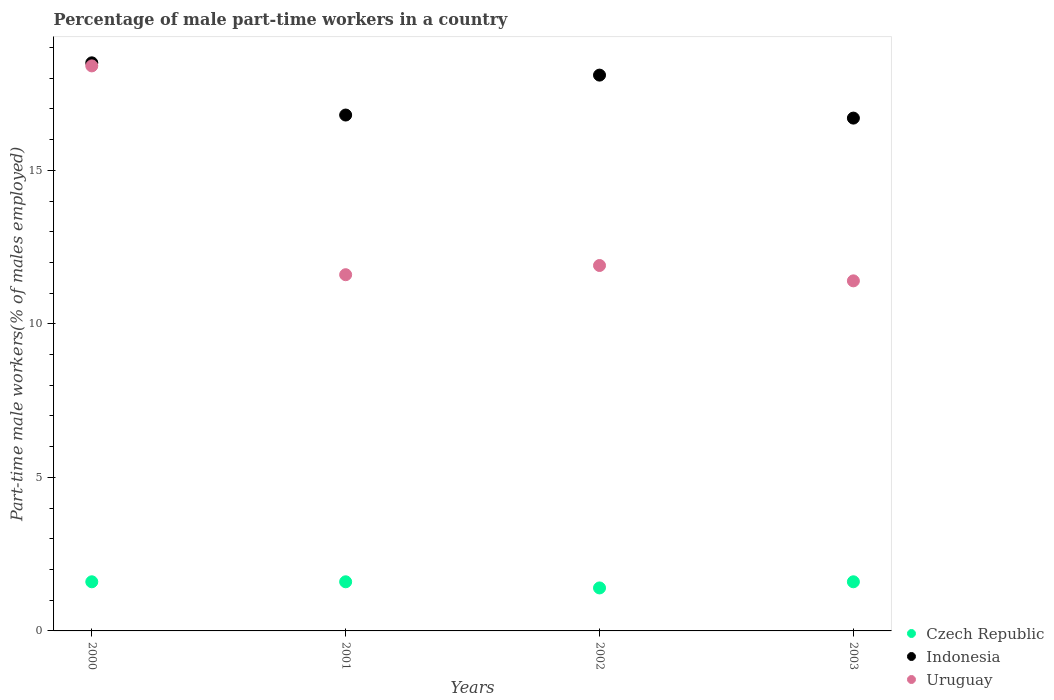Is the number of dotlines equal to the number of legend labels?
Ensure brevity in your answer.  Yes. What is the percentage of male part-time workers in Czech Republic in 2000?
Offer a very short reply. 1.6. Across all years, what is the maximum percentage of male part-time workers in Czech Republic?
Your answer should be very brief. 1.6. Across all years, what is the minimum percentage of male part-time workers in Uruguay?
Provide a short and direct response. 11.4. In which year was the percentage of male part-time workers in Indonesia minimum?
Provide a succinct answer. 2003. What is the total percentage of male part-time workers in Czech Republic in the graph?
Your answer should be compact. 6.2. What is the difference between the percentage of male part-time workers in Uruguay in 2003 and the percentage of male part-time workers in Indonesia in 2000?
Your response must be concise. -7.1. What is the average percentage of male part-time workers in Uruguay per year?
Your answer should be very brief. 13.32. In the year 2001, what is the difference between the percentage of male part-time workers in Uruguay and percentage of male part-time workers in Indonesia?
Offer a very short reply. -5.2. In how many years, is the percentage of male part-time workers in Czech Republic greater than 2 %?
Make the answer very short. 0. What is the ratio of the percentage of male part-time workers in Czech Republic in 2000 to that in 2003?
Your answer should be very brief. 1. Is the percentage of male part-time workers in Uruguay in 2001 less than that in 2003?
Offer a very short reply. No. Is the difference between the percentage of male part-time workers in Uruguay in 2001 and 2003 greater than the difference between the percentage of male part-time workers in Indonesia in 2001 and 2003?
Your answer should be very brief. Yes. What is the difference between the highest and the second highest percentage of male part-time workers in Indonesia?
Provide a succinct answer. 0.4. What is the difference between the highest and the lowest percentage of male part-time workers in Indonesia?
Provide a succinct answer. 1.8. Is the sum of the percentage of male part-time workers in Czech Republic in 2000 and 2001 greater than the maximum percentage of male part-time workers in Indonesia across all years?
Provide a succinct answer. No. Is it the case that in every year, the sum of the percentage of male part-time workers in Czech Republic and percentage of male part-time workers in Indonesia  is greater than the percentage of male part-time workers in Uruguay?
Make the answer very short. Yes. Does the percentage of male part-time workers in Uruguay monotonically increase over the years?
Your answer should be compact. No. Is the percentage of male part-time workers in Uruguay strictly less than the percentage of male part-time workers in Czech Republic over the years?
Give a very brief answer. No. How many dotlines are there?
Provide a succinct answer. 3. What is the difference between two consecutive major ticks on the Y-axis?
Offer a very short reply. 5. How many legend labels are there?
Give a very brief answer. 3. How are the legend labels stacked?
Provide a succinct answer. Vertical. What is the title of the graph?
Provide a succinct answer. Percentage of male part-time workers in a country. Does "Turks and Caicos Islands" appear as one of the legend labels in the graph?
Ensure brevity in your answer.  No. What is the label or title of the X-axis?
Provide a short and direct response. Years. What is the label or title of the Y-axis?
Offer a terse response. Part-time male workers(% of males employed). What is the Part-time male workers(% of males employed) in Czech Republic in 2000?
Give a very brief answer. 1.6. What is the Part-time male workers(% of males employed) in Indonesia in 2000?
Offer a terse response. 18.5. What is the Part-time male workers(% of males employed) in Uruguay in 2000?
Your answer should be compact. 18.4. What is the Part-time male workers(% of males employed) of Czech Republic in 2001?
Keep it short and to the point. 1.6. What is the Part-time male workers(% of males employed) in Indonesia in 2001?
Your answer should be very brief. 16.8. What is the Part-time male workers(% of males employed) in Uruguay in 2001?
Ensure brevity in your answer.  11.6. What is the Part-time male workers(% of males employed) of Czech Republic in 2002?
Your answer should be compact. 1.4. What is the Part-time male workers(% of males employed) in Indonesia in 2002?
Ensure brevity in your answer.  18.1. What is the Part-time male workers(% of males employed) of Uruguay in 2002?
Your answer should be compact. 11.9. What is the Part-time male workers(% of males employed) in Czech Republic in 2003?
Give a very brief answer. 1.6. What is the Part-time male workers(% of males employed) in Indonesia in 2003?
Provide a succinct answer. 16.7. What is the Part-time male workers(% of males employed) of Uruguay in 2003?
Ensure brevity in your answer.  11.4. Across all years, what is the maximum Part-time male workers(% of males employed) of Czech Republic?
Offer a very short reply. 1.6. Across all years, what is the maximum Part-time male workers(% of males employed) in Uruguay?
Your response must be concise. 18.4. Across all years, what is the minimum Part-time male workers(% of males employed) of Czech Republic?
Ensure brevity in your answer.  1.4. Across all years, what is the minimum Part-time male workers(% of males employed) of Indonesia?
Provide a short and direct response. 16.7. Across all years, what is the minimum Part-time male workers(% of males employed) in Uruguay?
Offer a terse response. 11.4. What is the total Part-time male workers(% of males employed) of Indonesia in the graph?
Offer a very short reply. 70.1. What is the total Part-time male workers(% of males employed) of Uruguay in the graph?
Make the answer very short. 53.3. What is the difference between the Part-time male workers(% of males employed) of Czech Republic in 2000 and that in 2001?
Make the answer very short. 0. What is the difference between the Part-time male workers(% of males employed) of Indonesia in 2000 and that in 2001?
Offer a terse response. 1.7. What is the difference between the Part-time male workers(% of males employed) in Czech Republic in 2000 and that in 2002?
Ensure brevity in your answer.  0.2. What is the difference between the Part-time male workers(% of males employed) in Uruguay in 2000 and that in 2002?
Offer a terse response. 6.5. What is the difference between the Part-time male workers(% of males employed) of Czech Republic in 2000 and that in 2003?
Provide a succinct answer. 0. What is the difference between the Part-time male workers(% of males employed) in Czech Republic in 2002 and that in 2003?
Provide a short and direct response. -0.2. What is the difference between the Part-time male workers(% of males employed) in Indonesia in 2002 and that in 2003?
Your response must be concise. 1.4. What is the difference between the Part-time male workers(% of males employed) in Czech Republic in 2000 and the Part-time male workers(% of males employed) in Indonesia in 2001?
Ensure brevity in your answer.  -15.2. What is the difference between the Part-time male workers(% of males employed) in Indonesia in 2000 and the Part-time male workers(% of males employed) in Uruguay in 2001?
Your answer should be compact. 6.9. What is the difference between the Part-time male workers(% of males employed) of Czech Republic in 2000 and the Part-time male workers(% of males employed) of Indonesia in 2002?
Offer a terse response. -16.5. What is the difference between the Part-time male workers(% of males employed) in Indonesia in 2000 and the Part-time male workers(% of males employed) in Uruguay in 2002?
Offer a terse response. 6.6. What is the difference between the Part-time male workers(% of males employed) in Czech Republic in 2000 and the Part-time male workers(% of males employed) in Indonesia in 2003?
Make the answer very short. -15.1. What is the difference between the Part-time male workers(% of males employed) of Czech Republic in 2001 and the Part-time male workers(% of males employed) of Indonesia in 2002?
Offer a very short reply. -16.5. What is the difference between the Part-time male workers(% of males employed) in Czech Republic in 2001 and the Part-time male workers(% of males employed) in Uruguay in 2002?
Your answer should be very brief. -10.3. What is the difference between the Part-time male workers(% of males employed) of Czech Republic in 2001 and the Part-time male workers(% of males employed) of Indonesia in 2003?
Give a very brief answer. -15.1. What is the difference between the Part-time male workers(% of males employed) of Czech Republic in 2002 and the Part-time male workers(% of males employed) of Indonesia in 2003?
Keep it short and to the point. -15.3. What is the difference between the Part-time male workers(% of males employed) of Czech Republic in 2002 and the Part-time male workers(% of males employed) of Uruguay in 2003?
Make the answer very short. -10. What is the difference between the Part-time male workers(% of males employed) of Indonesia in 2002 and the Part-time male workers(% of males employed) of Uruguay in 2003?
Your answer should be compact. 6.7. What is the average Part-time male workers(% of males employed) in Czech Republic per year?
Ensure brevity in your answer.  1.55. What is the average Part-time male workers(% of males employed) in Indonesia per year?
Keep it short and to the point. 17.52. What is the average Part-time male workers(% of males employed) in Uruguay per year?
Ensure brevity in your answer.  13.32. In the year 2000, what is the difference between the Part-time male workers(% of males employed) in Czech Republic and Part-time male workers(% of males employed) in Indonesia?
Offer a terse response. -16.9. In the year 2000, what is the difference between the Part-time male workers(% of males employed) in Czech Republic and Part-time male workers(% of males employed) in Uruguay?
Offer a very short reply. -16.8. In the year 2000, what is the difference between the Part-time male workers(% of males employed) of Indonesia and Part-time male workers(% of males employed) of Uruguay?
Offer a very short reply. 0.1. In the year 2001, what is the difference between the Part-time male workers(% of males employed) in Czech Republic and Part-time male workers(% of males employed) in Indonesia?
Your response must be concise. -15.2. In the year 2002, what is the difference between the Part-time male workers(% of males employed) in Czech Republic and Part-time male workers(% of males employed) in Indonesia?
Your response must be concise. -16.7. In the year 2002, what is the difference between the Part-time male workers(% of males employed) of Indonesia and Part-time male workers(% of males employed) of Uruguay?
Provide a short and direct response. 6.2. In the year 2003, what is the difference between the Part-time male workers(% of males employed) in Czech Republic and Part-time male workers(% of males employed) in Indonesia?
Ensure brevity in your answer.  -15.1. In the year 2003, what is the difference between the Part-time male workers(% of males employed) of Czech Republic and Part-time male workers(% of males employed) of Uruguay?
Your answer should be very brief. -9.8. In the year 2003, what is the difference between the Part-time male workers(% of males employed) in Indonesia and Part-time male workers(% of males employed) in Uruguay?
Give a very brief answer. 5.3. What is the ratio of the Part-time male workers(% of males employed) of Indonesia in 2000 to that in 2001?
Offer a very short reply. 1.1. What is the ratio of the Part-time male workers(% of males employed) in Uruguay in 2000 to that in 2001?
Your answer should be compact. 1.59. What is the ratio of the Part-time male workers(% of males employed) in Czech Republic in 2000 to that in 2002?
Ensure brevity in your answer.  1.14. What is the ratio of the Part-time male workers(% of males employed) of Indonesia in 2000 to that in 2002?
Give a very brief answer. 1.02. What is the ratio of the Part-time male workers(% of males employed) in Uruguay in 2000 to that in 2002?
Give a very brief answer. 1.55. What is the ratio of the Part-time male workers(% of males employed) of Indonesia in 2000 to that in 2003?
Your answer should be very brief. 1.11. What is the ratio of the Part-time male workers(% of males employed) of Uruguay in 2000 to that in 2003?
Provide a short and direct response. 1.61. What is the ratio of the Part-time male workers(% of males employed) of Czech Republic in 2001 to that in 2002?
Provide a succinct answer. 1.14. What is the ratio of the Part-time male workers(% of males employed) in Indonesia in 2001 to that in 2002?
Offer a very short reply. 0.93. What is the ratio of the Part-time male workers(% of males employed) in Uruguay in 2001 to that in 2002?
Offer a terse response. 0.97. What is the ratio of the Part-time male workers(% of males employed) of Uruguay in 2001 to that in 2003?
Provide a succinct answer. 1.02. What is the ratio of the Part-time male workers(% of males employed) of Czech Republic in 2002 to that in 2003?
Offer a very short reply. 0.88. What is the ratio of the Part-time male workers(% of males employed) of Indonesia in 2002 to that in 2003?
Keep it short and to the point. 1.08. What is the ratio of the Part-time male workers(% of males employed) in Uruguay in 2002 to that in 2003?
Make the answer very short. 1.04. What is the difference between the highest and the second highest Part-time male workers(% of males employed) in Uruguay?
Make the answer very short. 6.5. What is the difference between the highest and the lowest Part-time male workers(% of males employed) in Indonesia?
Your answer should be compact. 1.8. What is the difference between the highest and the lowest Part-time male workers(% of males employed) of Uruguay?
Make the answer very short. 7. 